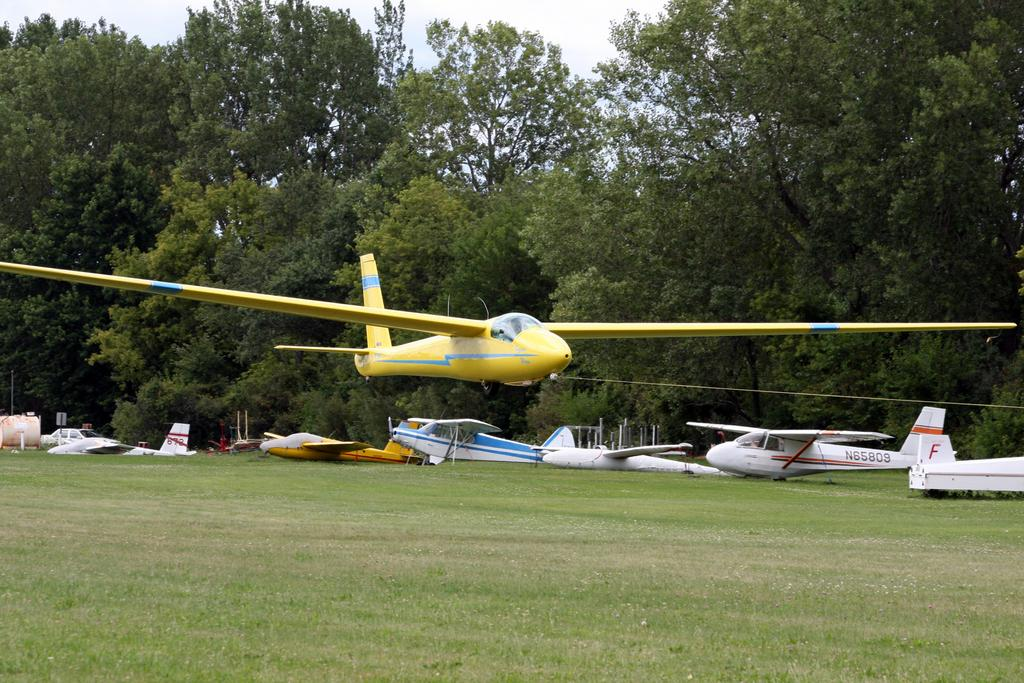What is the main subject of the image? The main subject of the image is fleets of aircrafts on the grass. Can you describe the position of some aircrafts in the image? Some aircrafts are in the air. What can be seen in the background of the image? In the background of the image, there are trees, light poles, boards, and the sky. What might be the location of the image? The image may have been taken in a park. What type of nation is being celebrated in the image? There is no indication of a nation being celebrated in the image; it primarily features aircrafts on the grass and in the air. What process is being carried out by the cakes in the image? There are no cakes present in the image. 